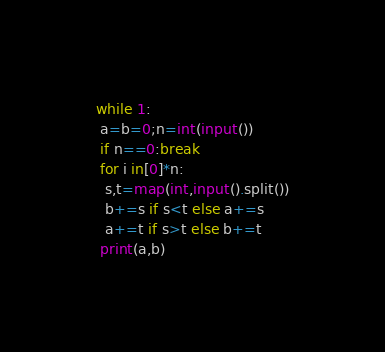Convert code to text. <code><loc_0><loc_0><loc_500><loc_500><_Python_>while 1:
 a=b=0;n=int(input())
 if n==0:break
 for i in[0]*n:
  s,t=map(int,input().split())
  b+=s if s<t else a+=s
  a+=t if s>t else b+=t
 print(a,b)
</code> 